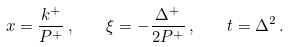Convert formula to latex. <formula><loc_0><loc_0><loc_500><loc_500>x = \frac { k ^ { + } } { P ^ { + } } \, , \quad \xi = - \frac { \Delta ^ { + } } { 2 P ^ { + } } \, , \quad t = \Delta ^ { 2 } \, .</formula> 